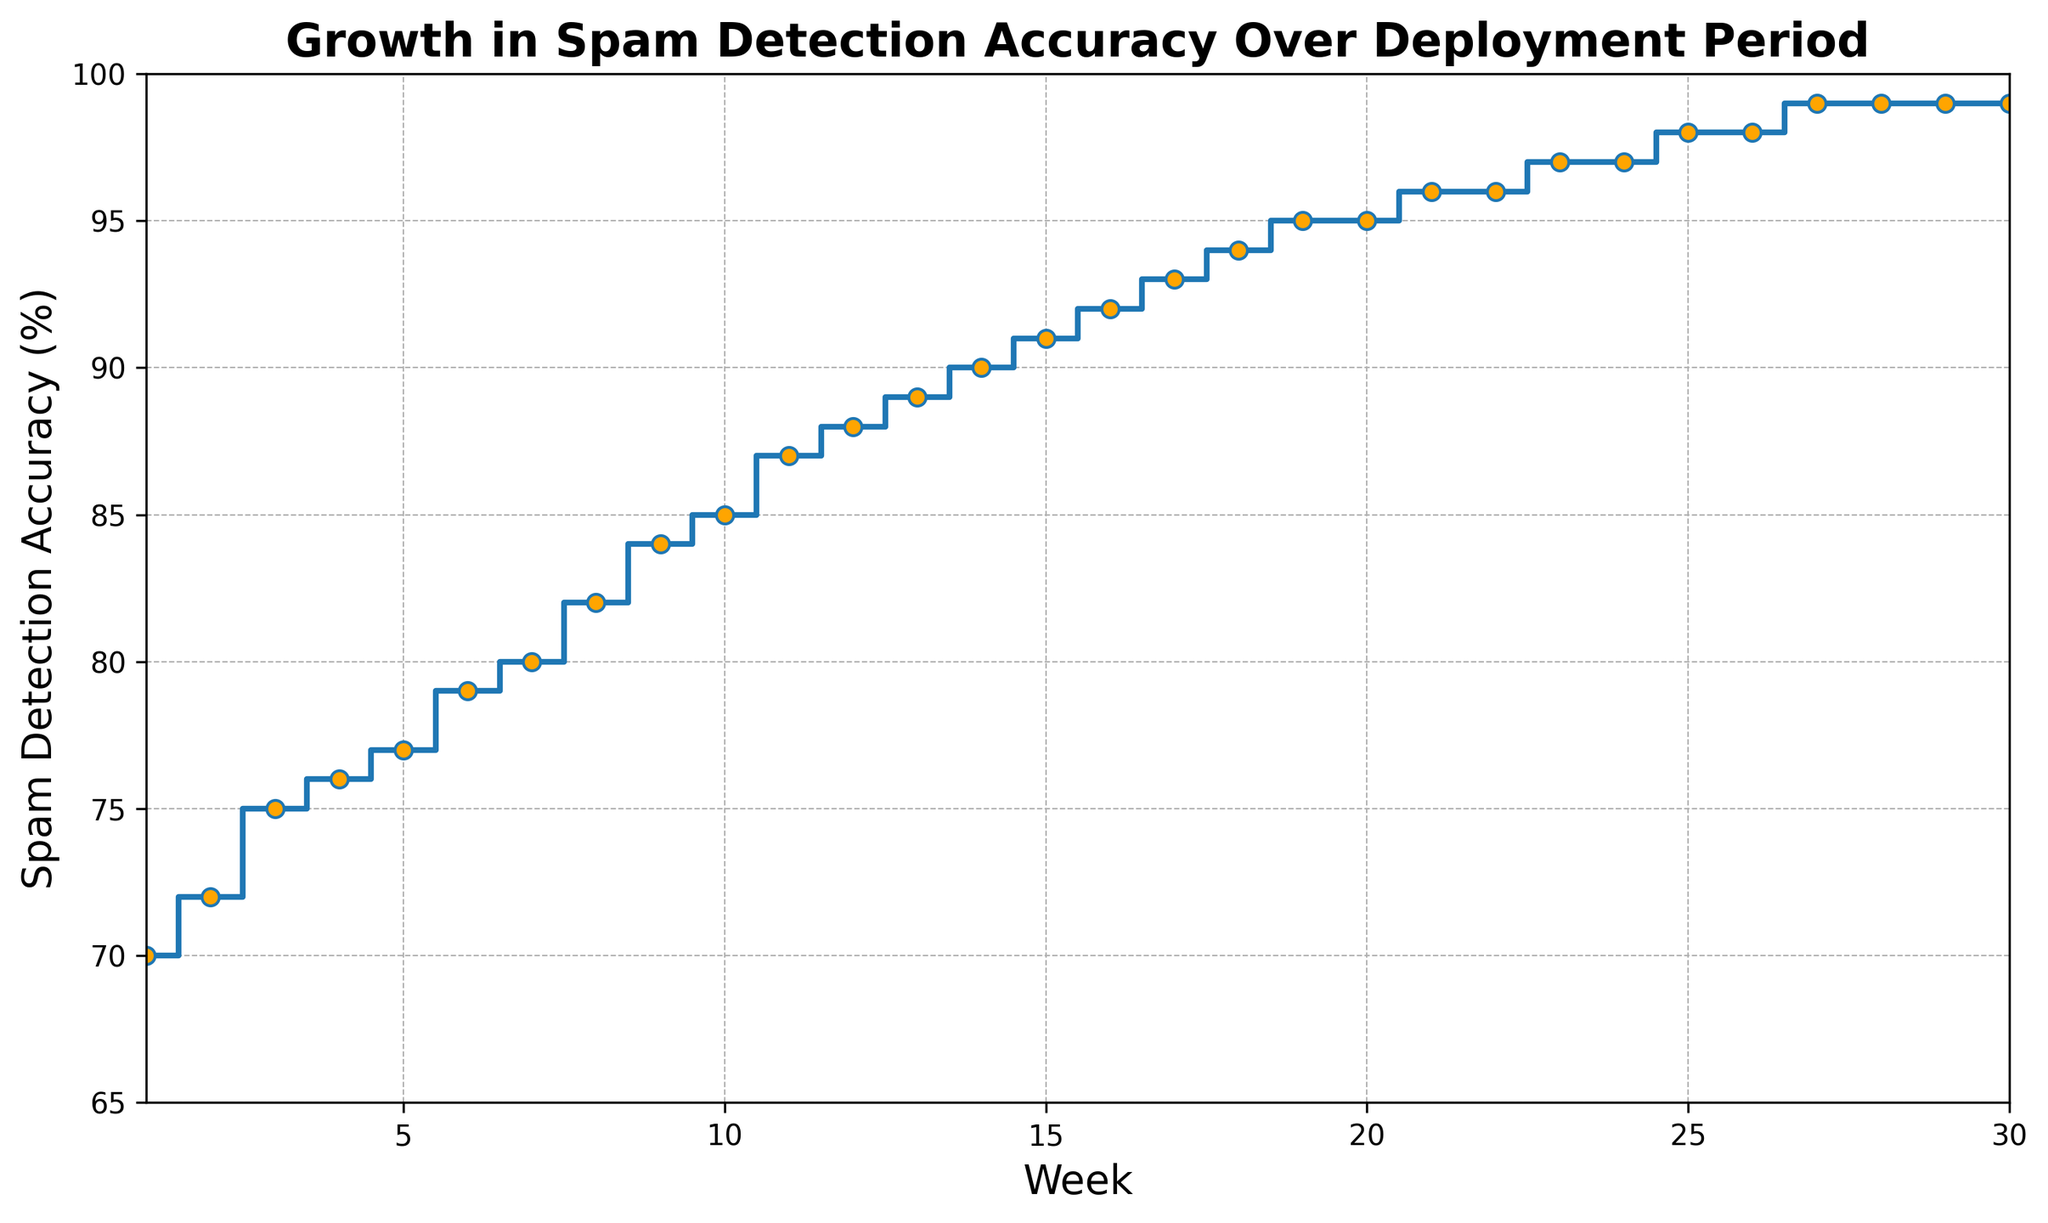What is the spam detection accuracy at Week 15? Look at the point corresponding to Week 15 on the x-axis and check the y-axis value for spam detection accuracy at that point.
Answer: 91% Which week saw the highest increase in spam detection accuracy? To determine this, observe the biggest vertical rise between any two consecutive steps. The largest increase is from Week 12 to Week 13, where the accuracy goes from 88% to 89%, a 1% increase.
Answer: Week 13 By how much did the spam detection accuracy increase from Week 1 to Week 30? Observe the starting value at Week 1 (70%) and the ending value at Week 30 (99%). The increase is calculated as 99% - 70%.
Answer: 29% What is the difference in spam detection accuracy between Week 8 and Week 12? Locate the values for Week 8 (82%) and Week 12 (88%) and compute the difference: 88% - 82%.
Answer: 6% Was there any week where the accuracy did not increase? Look for any flat lines (no vertical rise) between two consecutive weeks. This situation is observed between Week 20 to Week 21, and Week 22 to Week 23, and Week 24 to Week 25.
Answer: Yes What is the average spam detection accuracy over the first 10 weeks? Sum the accuracy values for the first 10 weeks (70 + 72 + 75 + 76 + 77 + 79 + 80 + 82 + 84 + 85) and divide by 10. (784 / 10).
Answer: 78.4% Is the overall trend in spam detection improvement upward or downward? Observe the overall direction of the steps on the plot; they mostly move upward, indicating an increasing trend.
Answer: Upward Between which week span does the spam detection accuracy reach 90%? Check the plot for the first point where the spam detection accuracy hits 90%. It occurs between Week 13 (89%) and Week 14 (90%).
Answer: Week 13 to Week 14 What is the visual difference in the plot between Week 1 and Week 30? Week 1 starts at a lower position (70%) on the y-axis, and Week 30 is near the top (99%). The line connecting these weeks steps progressively upward.
Answer: The plot starts low and ends high How many weeks did it take to reach a spam detection accuracy of 95%? Identify the week where the accuracy first reaches 95%, which is Week 19.
Answer: 19 weeks 